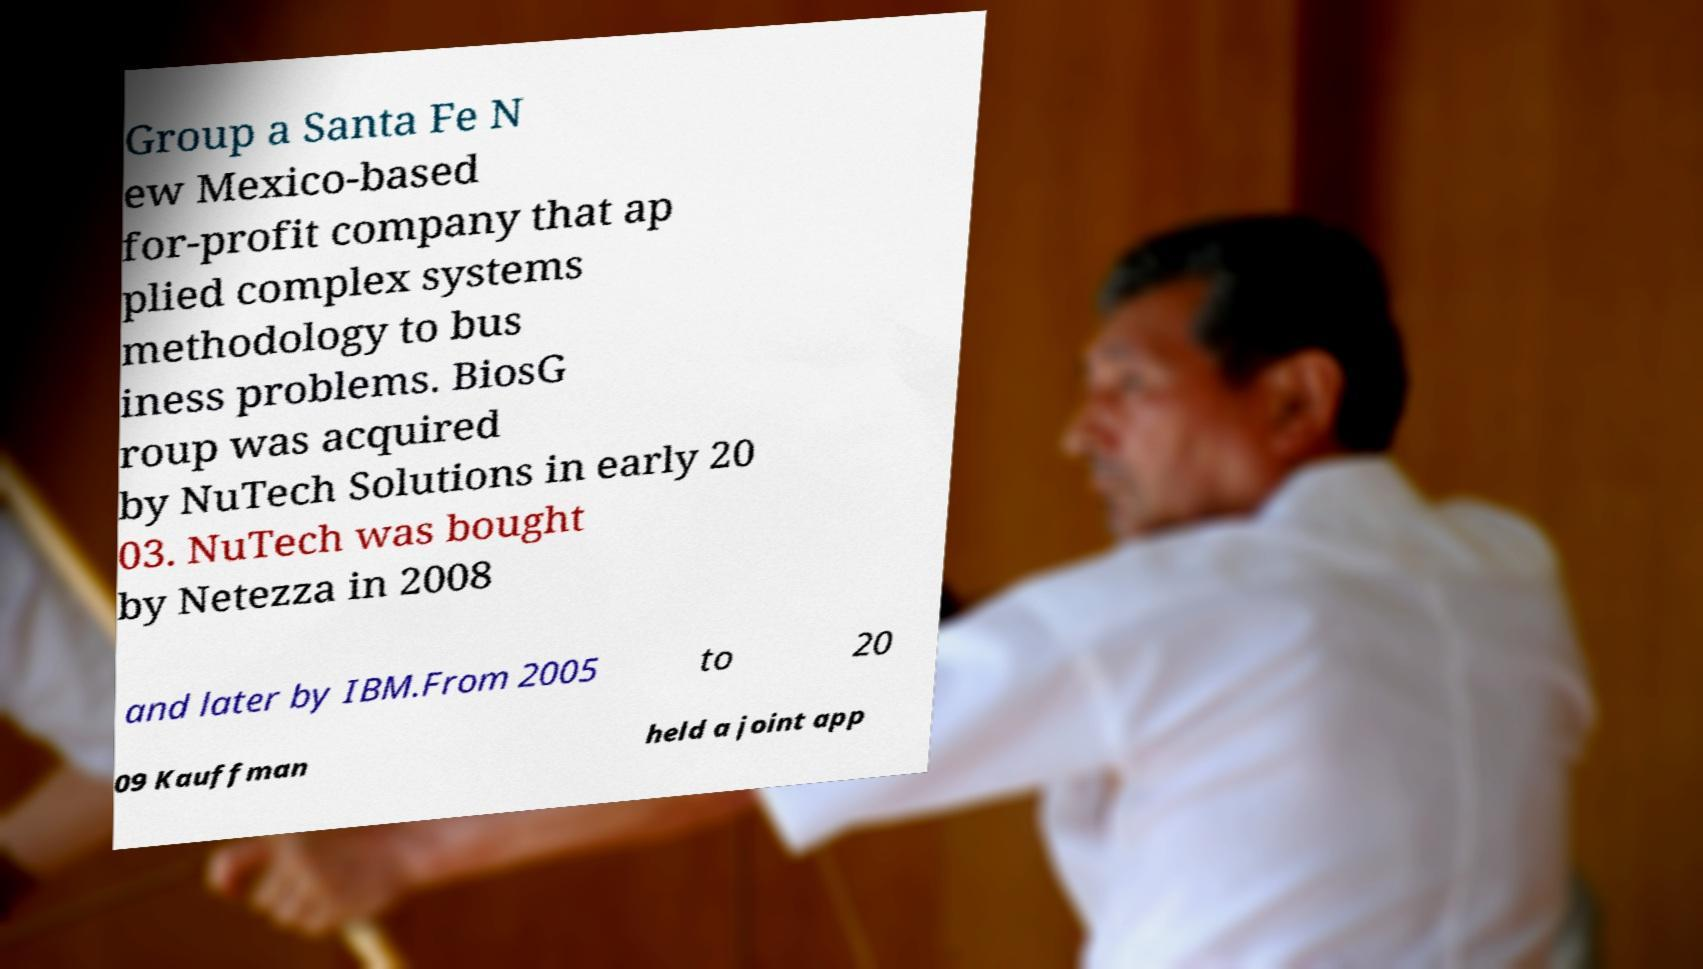What messages or text are displayed in this image? I need them in a readable, typed format. Group a Santa Fe N ew Mexico-based for-profit company that ap plied complex systems methodology to bus iness problems. BiosG roup was acquired by NuTech Solutions in early 20 03. NuTech was bought by Netezza in 2008 and later by IBM.From 2005 to 20 09 Kauffman held a joint app 